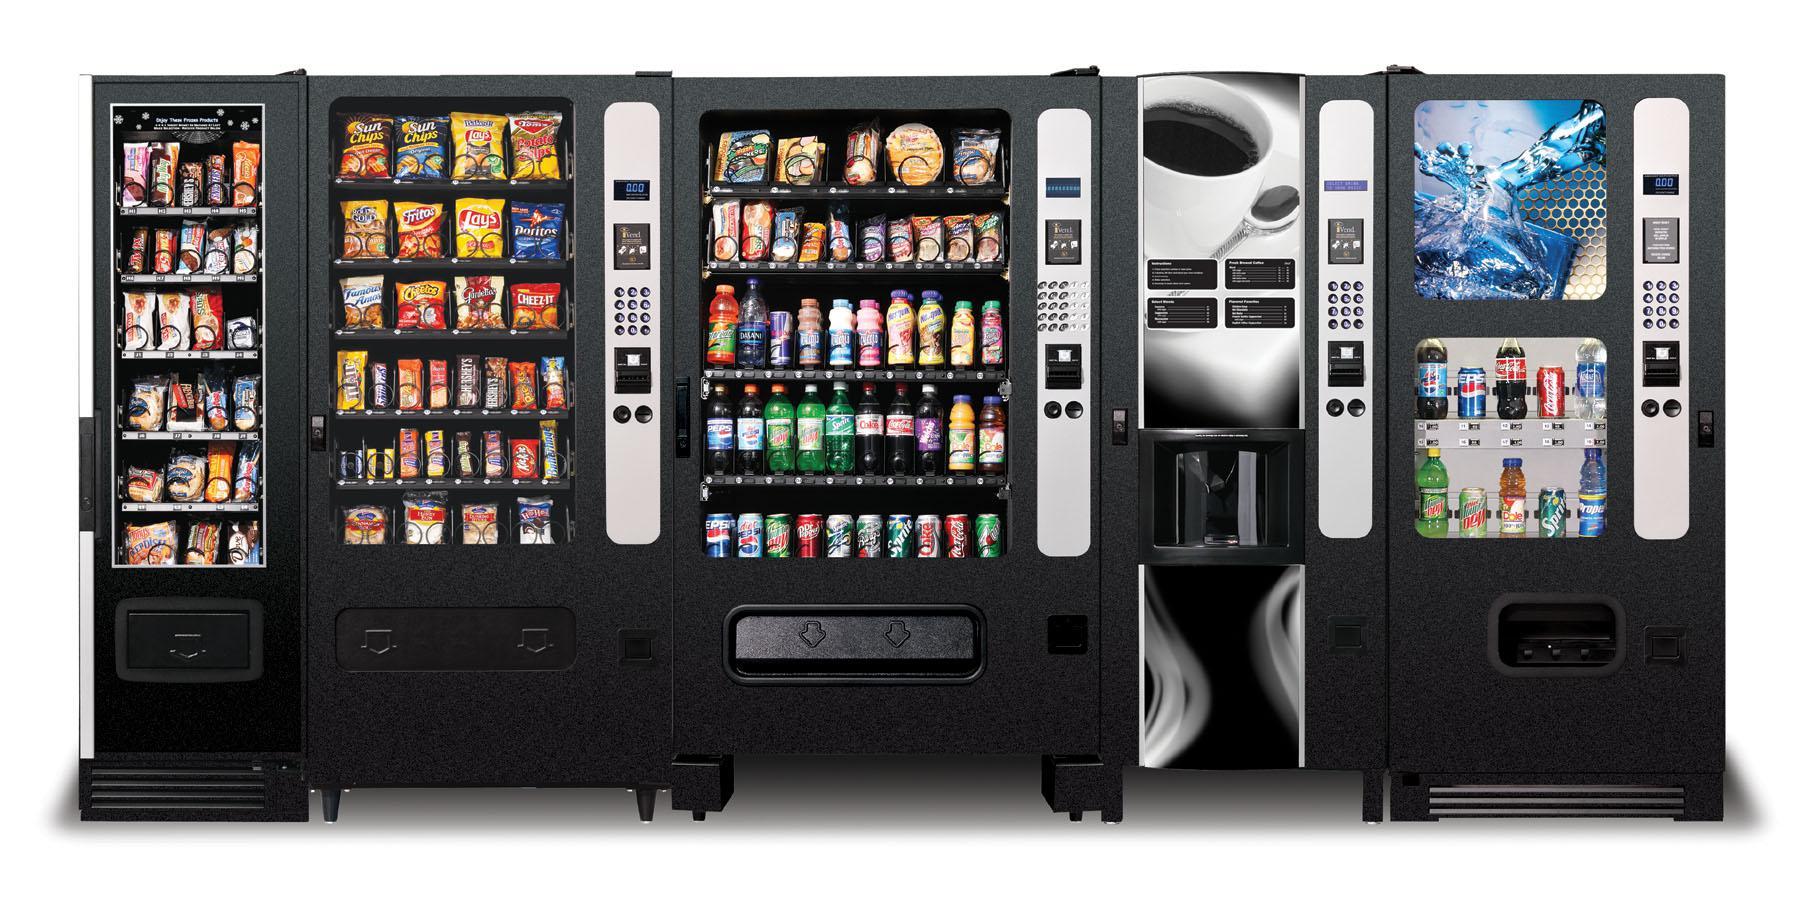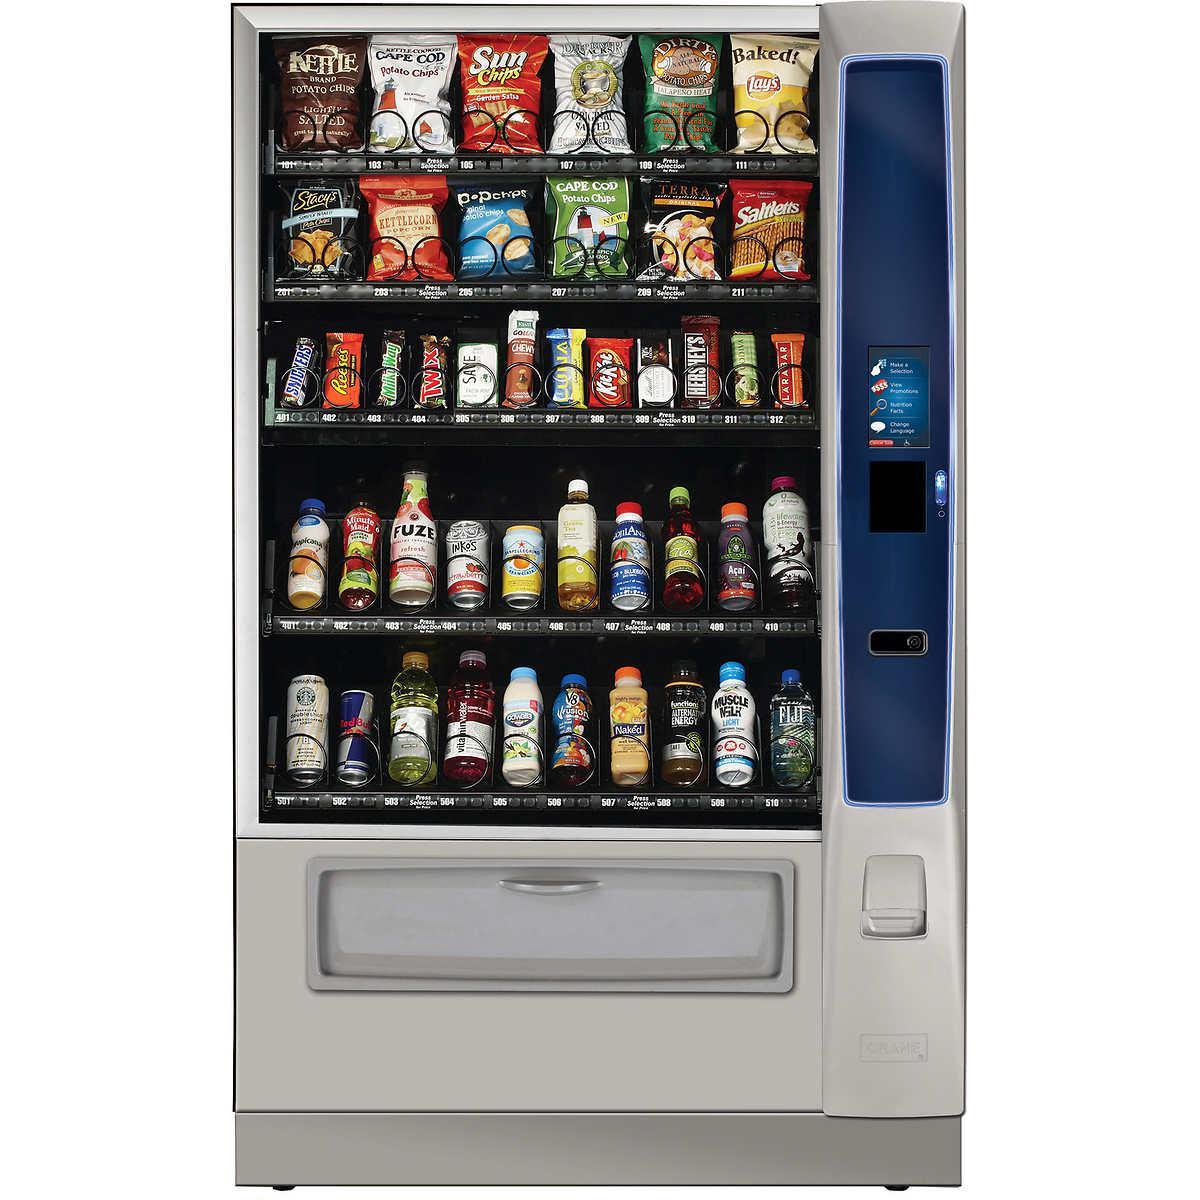The first image is the image on the left, the second image is the image on the right. Considering the images on both sides, is "A bank of four vending machines is shown in one image." valid? Answer yes or no. Yes. The first image is the image on the left, the second image is the image on the right. Given the left and right images, does the statement "There are at most three vending machines in total." hold true? Answer yes or no. No. 